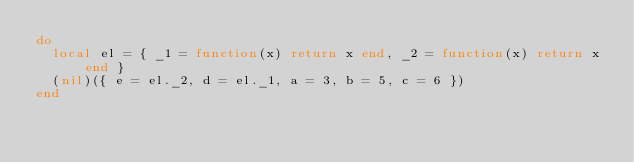Convert code to text. <code><loc_0><loc_0><loc_500><loc_500><_Lua_>do
  local el = { _1 = function(x) return x end, _2 = function(x) return x end }
  (nil)({ e = el._2, d = el._1, a = 3, b = 5, c = 6 })
end
</code> 